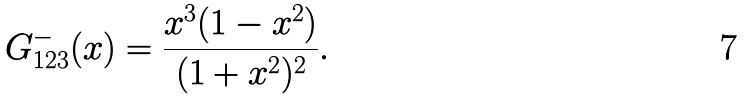Convert formula to latex. <formula><loc_0><loc_0><loc_500><loc_500>G ^ { - } _ { 1 2 3 } ( x ) = \frac { x ^ { 3 } ( 1 - x ^ { 2 } ) } { ( 1 + x ^ { 2 } ) ^ { 2 } } .</formula> 